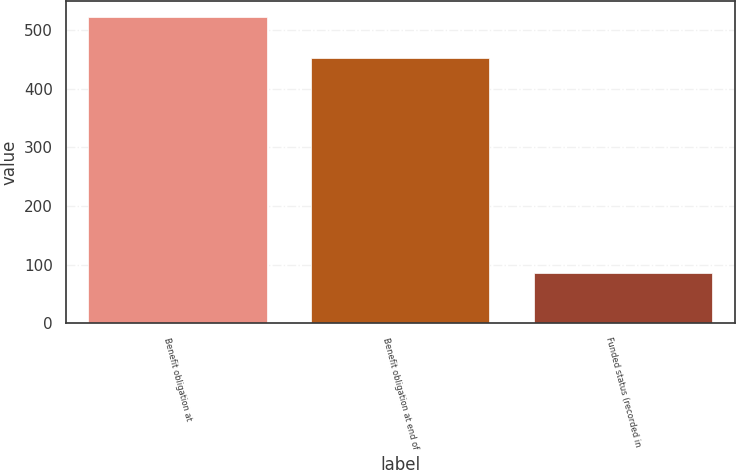Convert chart to OTSL. <chart><loc_0><loc_0><loc_500><loc_500><bar_chart><fcel>Benefit obligation at<fcel>Benefit obligation at end of<fcel>Funded status (recorded in<nl><fcel>523<fcel>452<fcel>85<nl></chart> 